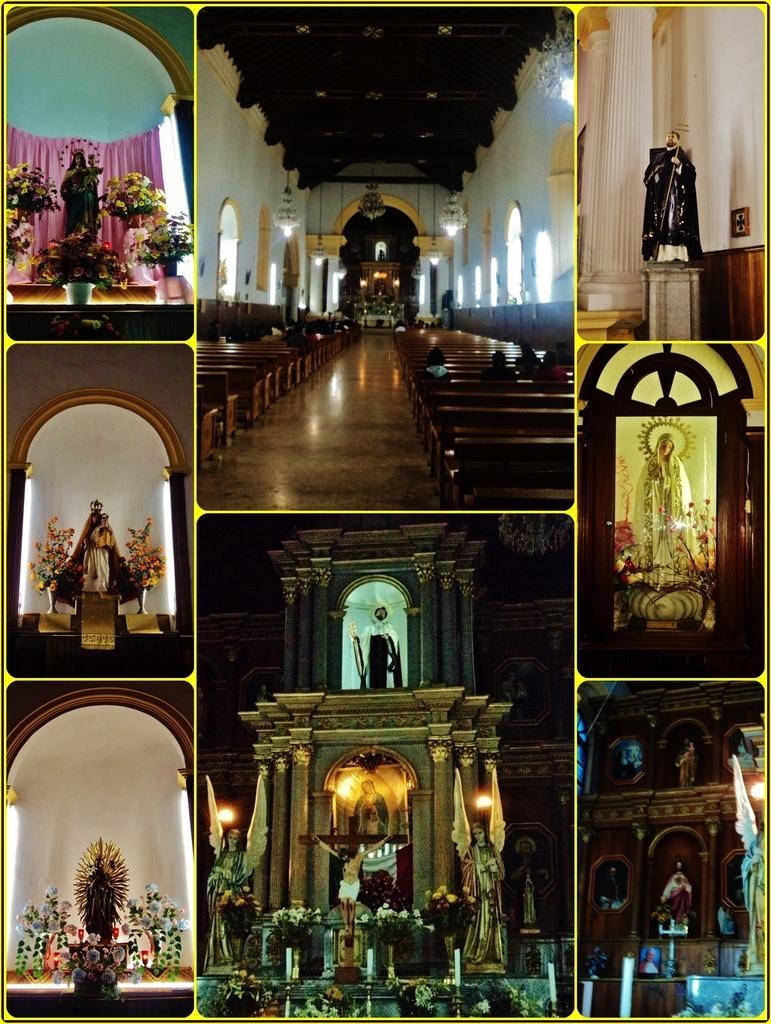Could you give a brief overview of what you see in this image? This is an image with collage. In this image we can see a statue, curtain and some flower pots. A building with stone pillars and benches and some candles. 